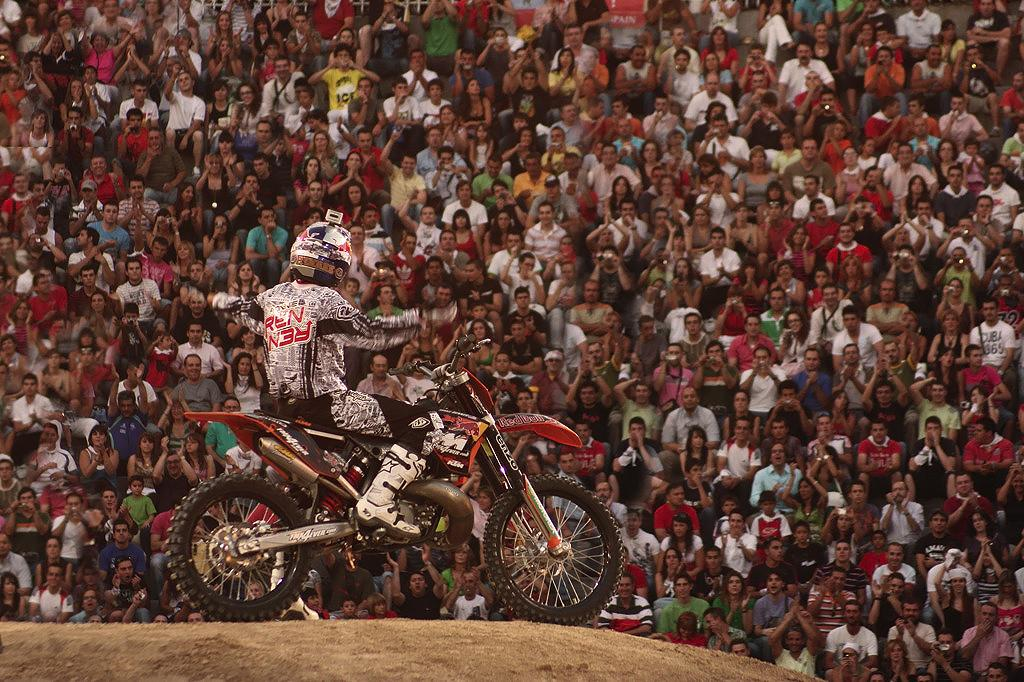What is the main subject of the image? The main subject of the image is a racer. What is the racer doing in the image? The racer is sitting on a bike. What is the reaction of the people around the racer? The crowd surrounding the racer is cheering. What type of calendar is hanging on the wall behind the racer? There is no calendar present in the image. What kind of quilt is covering the racer's bike? There is no quilt present in the image; the racer is sitting on a bike without any covering. 